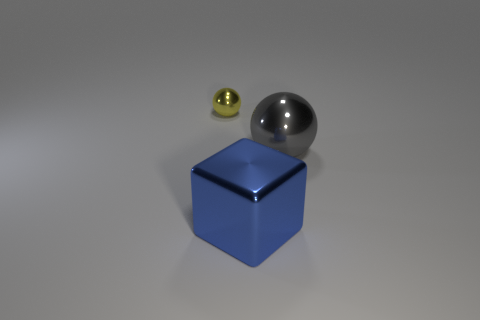What is the size of the sphere that is in front of the shiny ball that is behind the gray ball?
Offer a very short reply. Large. What number of small objects are either gray metallic spheres or gray rubber blocks?
Your answer should be very brief. 0. What is the size of the shiny ball that is left of the shiny object that is in front of the ball that is in front of the yellow sphere?
Give a very brief answer. Small. Is there anything else that has the same color as the big ball?
Provide a succinct answer. No. The ball that is right of the shiny object that is behind the ball that is in front of the yellow metal ball is made of what material?
Give a very brief answer. Metal. Do the tiny thing and the gray thing have the same shape?
Ensure brevity in your answer.  Yes. What number of objects are both in front of the small shiny thing and left of the blue metallic object?
Provide a short and direct response. 0. What color is the thing that is in front of the ball right of the blue metal object?
Offer a very short reply. Blue. Is the number of yellow shiny balls that are to the left of the blue object the same as the number of blue metal cubes?
Your answer should be very brief. Yes. What number of large metallic objects are left of the metallic sphere that is to the right of the metallic object that is behind the big gray shiny ball?
Your answer should be compact. 1. 